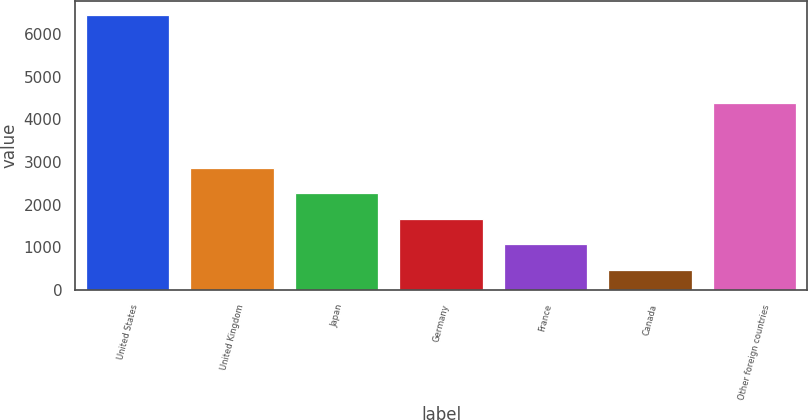Convert chart. <chart><loc_0><loc_0><loc_500><loc_500><bar_chart><fcel>United States<fcel>United Kingdom<fcel>Japan<fcel>Germany<fcel>France<fcel>Canada<fcel>Other foreign countries<nl><fcel>6449<fcel>2862.8<fcel>2265.1<fcel>1667.4<fcel>1069.7<fcel>472<fcel>4377<nl></chart> 